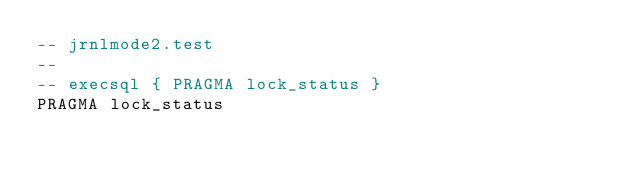Convert code to text. <code><loc_0><loc_0><loc_500><loc_500><_SQL_>-- jrnlmode2.test
-- 
-- execsql { PRAGMA lock_status }
PRAGMA lock_status</code> 